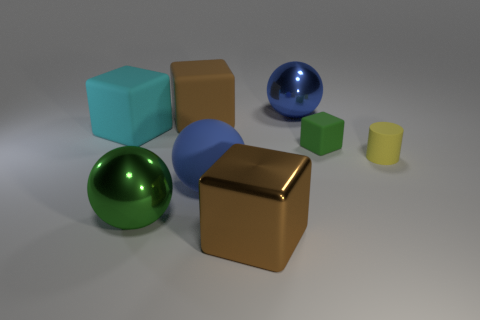There is a green object that is behind the small matte cylinder; what is its size?
Keep it short and to the point. Small. What is the material of the big green object?
Ensure brevity in your answer.  Metal. Is the shape of the matte object to the left of the large green object the same as  the blue metallic thing?
Make the answer very short. No. Is there a matte cylinder that has the same size as the green rubber thing?
Offer a very short reply. Yes. Is there a metallic thing in front of the big brown cube that is behind the brown object that is in front of the large cyan cube?
Provide a succinct answer. Yes. Do the small cube and the shiny sphere that is on the left side of the brown shiny object have the same color?
Give a very brief answer. Yes. What is the material of the cube that is in front of the shiny sphere to the left of the brown thing in front of the large green object?
Offer a terse response. Metal. What shape is the large blue object that is in front of the big cyan matte block?
Give a very brief answer. Sphere. The green block that is made of the same material as the small yellow object is what size?
Make the answer very short. Small. What number of brown metallic objects have the same shape as the green matte thing?
Offer a very short reply. 1. 